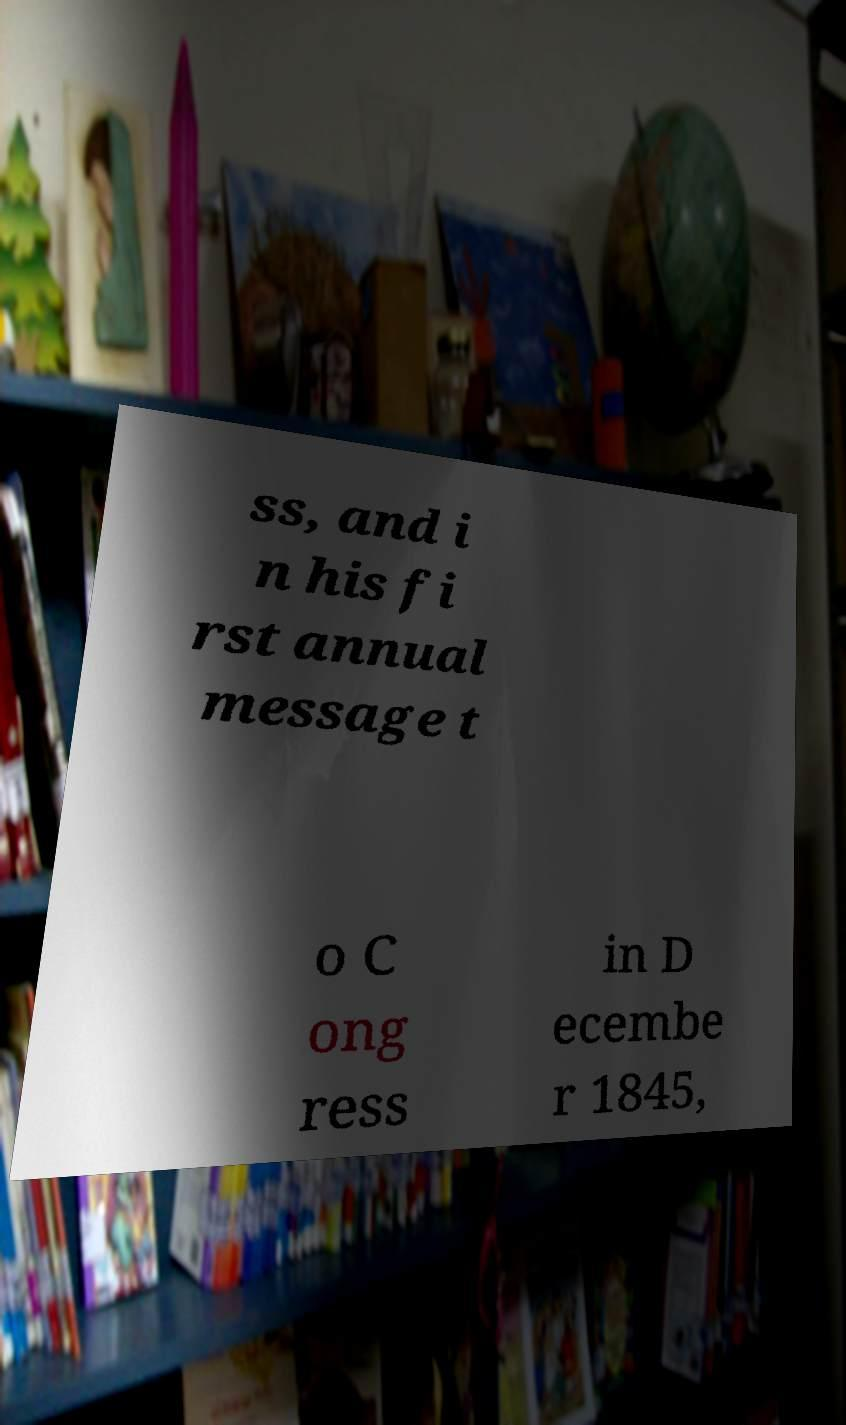For documentation purposes, I need the text within this image transcribed. Could you provide that? ss, and i n his fi rst annual message t o C ong ress in D ecembe r 1845, 